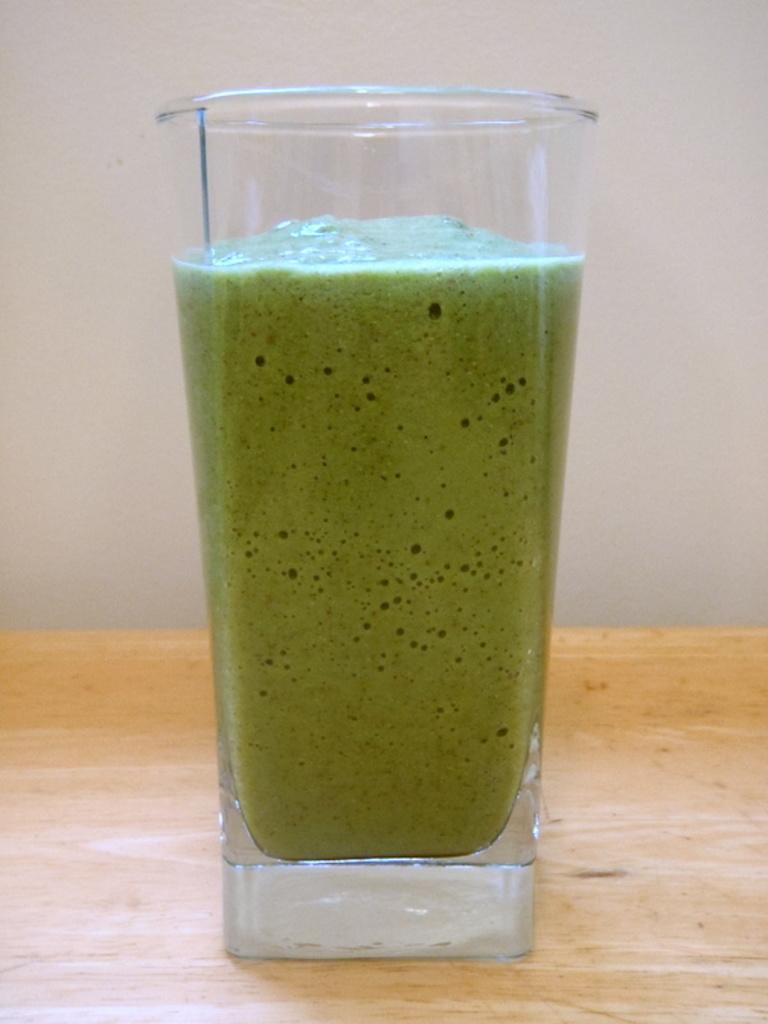Describe this image in one or two sentences. Here in this picture we can see a glass of juice present on a table. 